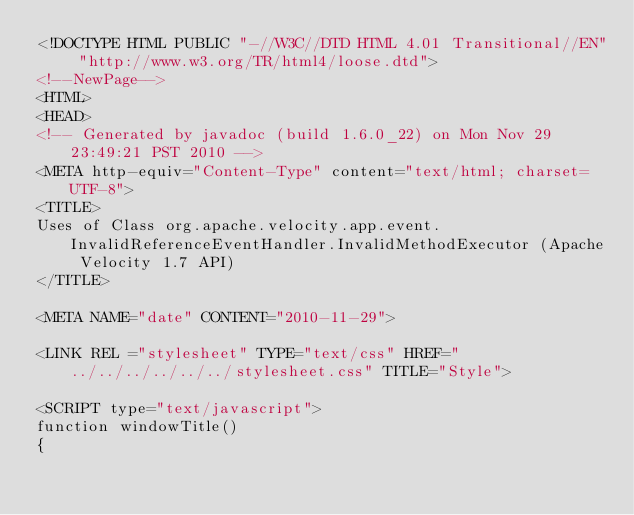Convert code to text. <code><loc_0><loc_0><loc_500><loc_500><_HTML_><!DOCTYPE HTML PUBLIC "-//W3C//DTD HTML 4.01 Transitional//EN" "http://www.w3.org/TR/html4/loose.dtd">
<!--NewPage-->
<HTML>
<HEAD>
<!-- Generated by javadoc (build 1.6.0_22) on Mon Nov 29 23:49:21 PST 2010 -->
<META http-equiv="Content-Type" content="text/html; charset=UTF-8">
<TITLE>
Uses of Class org.apache.velocity.app.event.InvalidReferenceEventHandler.InvalidMethodExecutor (Apache Velocity 1.7 API)
</TITLE>

<META NAME="date" CONTENT="2010-11-29">

<LINK REL ="stylesheet" TYPE="text/css" HREF="../../../../../../stylesheet.css" TITLE="Style">

<SCRIPT type="text/javascript">
function windowTitle()
{</code> 